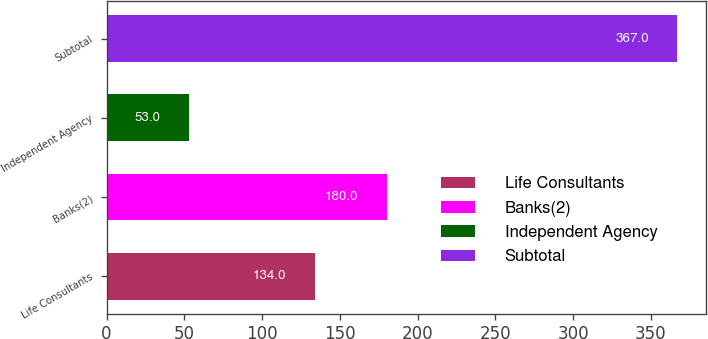Convert chart to OTSL. <chart><loc_0><loc_0><loc_500><loc_500><bar_chart><fcel>Life Consultants<fcel>Banks(2)<fcel>Independent Agency<fcel>Subtotal<nl><fcel>134<fcel>180<fcel>53<fcel>367<nl></chart> 